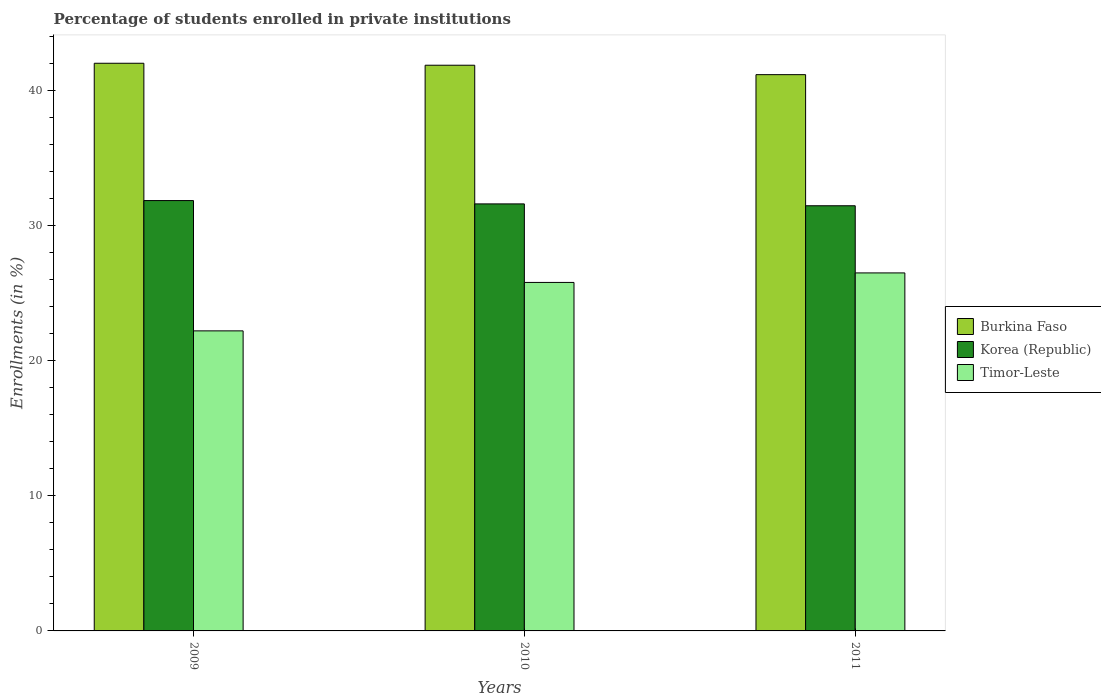How many groups of bars are there?
Offer a terse response. 3. Are the number of bars per tick equal to the number of legend labels?
Your answer should be very brief. Yes. Are the number of bars on each tick of the X-axis equal?
Make the answer very short. Yes. How many bars are there on the 2nd tick from the left?
Keep it short and to the point. 3. How many bars are there on the 2nd tick from the right?
Your answer should be compact. 3. What is the label of the 3rd group of bars from the left?
Make the answer very short. 2011. In how many cases, is the number of bars for a given year not equal to the number of legend labels?
Provide a short and direct response. 0. What is the percentage of trained teachers in Timor-Leste in 2011?
Give a very brief answer. 26.49. Across all years, what is the maximum percentage of trained teachers in Timor-Leste?
Your response must be concise. 26.49. Across all years, what is the minimum percentage of trained teachers in Burkina Faso?
Make the answer very short. 41.16. What is the total percentage of trained teachers in Timor-Leste in the graph?
Give a very brief answer. 74.48. What is the difference between the percentage of trained teachers in Timor-Leste in 2009 and that in 2011?
Your response must be concise. -4.29. What is the difference between the percentage of trained teachers in Burkina Faso in 2011 and the percentage of trained teachers in Korea (Republic) in 2010?
Provide a short and direct response. 9.56. What is the average percentage of trained teachers in Korea (Republic) per year?
Make the answer very short. 31.63. In the year 2010, what is the difference between the percentage of trained teachers in Korea (Republic) and percentage of trained teachers in Burkina Faso?
Provide a succinct answer. -10.26. What is the ratio of the percentage of trained teachers in Burkina Faso in 2009 to that in 2011?
Your answer should be compact. 1.02. Is the difference between the percentage of trained teachers in Korea (Republic) in 2009 and 2010 greater than the difference between the percentage of trained teachers in Burkina Faso in 2009 and 2010?
Give a very brief answer. Yes. What is the difference between the highest and the second highest percentage of trained teachers in Burkina Faso?
Make the answer very short. 0.15. What is the difference between the highest and the lowest percentage of trained teachers in Burkina Faso?
Keep it short and to the point. 0.84. Is the sum of the percentage of trained teachers in Korea (Republic) in 2010 and 2011 greater than the maximum percentage of trained teachers in Burkina Faso across all years?
Ensure brevity in your answer.  Yes. What does the 3rd bar from the left in 2009 represents?
Your response must be concise. Timor-Leste. What does the 2nd bar from the right in 2010 represents?
Keep it short and to the point. Korea (Republic). Is it the case that in every year, the sum of the percentage of trained teachers in Burkina Faso and percentage of trained teachers in Timor-Leste is greater than the percentage of trained teachers in Korea (Republic)?
Offer a very short reply. Yes. How many bars are there?
Offer a very short reply. 9. Are all the bars in the graph horizontal?
Provide a succinct answer. No. How many years are there in the graph?
Provide a succinct answer. 3. What is the difference between two consecutive major ticks on the Y-axis?
Offer a very short reply. 10. Does the graph contain any zero values?
Your response must be concise. No. What is the title of the graph?
Make the answer very short. Percentage of students enrolled in private institutions. What is the label or title of the Y-axis?
Your response must be concise. Enrollments (in %). What is the Enrollments (in %) in Burkina Faso in 2009?
Your answer should be very brief. 42. What is the Enrollments (in %) of Korea (Republic) in 2009?
Your answer should be compact. 31.84. What is the Enrollments (in %) in Timor-Leste in 2009?
Give a very brief answer. 22.2. What is the Enrollments (in %) of Burkina Faso in 2010?
Your response must be concise. 41.86. What is the Enrollments (in %) of Korea (Republic) in 2010?
Make the answer very short. 31.6. What is the Enrollments (in %) of Timor-Leste in 2010?
Offer a very short reply. 25.79. What is the Enrollments (in %) in Burkina Faso in 2011?
Make the answer very short. 41.16. What is the Enrollments (in %) of Korea (Republic) in 2011?
Keep it short and to the point. 31.46. What is the Enrollments (in %) of Timor-Leste in 2011?
Give a very brief answer. 26.49. Across all years, what is the maximum Enrollments (in %) of Burkina Faso?
Provide a succinct answer. 42. Across all years, what is the maximum Enrollments (in %) of Korea (Republic)?
Keep it short and to the point. 31.84. Across all years, what is the maximum Enrollments (in %) in Timor-Leste?
Give a very brief answer. 26.49. Across all years, what is the minimum Enrollments (in %) of Burkina Faso?
Give a very brief answer. 41.16. Across all years, what is the minimum Enrollments (in %) of Korea (Republic)?
Offer a terse response. 31.46. Across all years, what is the minimum Enrollments (in %) of Timor-Leste?
Offer a very short reply. 22.2. What is the total Enrollments (in %) of Burkina Faso in the graph?
Your answer should be compact. 125.02. What is the total Enrollments (in %) of Korea (Republic) in the graph?
Keep it short and to the point. 94.9. What is the total Enrollments (in %) of Timor-Leste in the graph?
Offer a very short reply. 74.48. What is the difference between the Enrollments (in %) of Burkina Faso in 2009 and that in 2010?
Ensure brevity in your answer.  0.15. What is the difference between the Enrollments (in %) of Korea (Republic) in 2009 and that in 2010?
Ensure brevity in your answer.  0.25. What is the difference between the Enrollments (in %) of Timor-Leste in 2009 and that in 2010?
Offer a terse response. -3.58. What is the difference between the Enrollments (in %) in Burkina Faso in 2009 and that in 2011?
Your response must be concise. 0.84. What is the difference between the Enrollments (in %) in Korea (Republic) in 2009 and that in 2011?
Offer a very short reply. 0.38. What is the difference between the Enrollments (in %) of Timor-Leste in 2009 and that in 2011?
Offer a terse response. -4.29. What is the difference between the Enrollments (in %) of Burkina Faso in 2010 and that in 2011?
Offer a terse response. 0.7. What is the difference between the Enrollments (in %) in Korea (Republic) in 2010 and that in 2011?
Provide a short and direct response. 0.14. What is the difference between the Enrollments (in %) of Timor-Leste in 2010 and that in 2011?
Give a very brief answer. -0.7. What is the difference between the Enrollments (in %) in Burkina Faso in 2009 and the Enrollments (in %) in Korea (Republic) in 2010?
Ensure brevity in your answer.  10.41. What is the difference between the Enrollments (in %) in Burkina Faso in 2009 and the Enrollments (in %) in Timor-Leste in 2010?
Ensure brevity in your answer.  16.22. What is the difference between the Enrollments (in %) in Korea (Republic) in 2009 and the Enrollments (in %) in Timor-Leste in 2010?
Make the answer very short. 6.06. What is the difference between the Enrollments (in %) in Burkina Faso in 2009 and the Enrollments (in %) in Korea (Republic) in 2011?
Your response must be concise. 10.54. What is the difference between the Enrollments (in %) of Burkina Faso in 2009 and the Enrollments (in %) of Timor-Leste in 2011?
Offer a terse response. 15.51. What is the difference between the Enrollments (in %) in Korea (Republic) in 2009 and the Enrollments (in %) in Timor-Leste in 2011?
Provide a short and direct response. 5.35. What is the difference between the Enrollments (in %) in Burkina Faso in 2010 and the Enrollments (in %) in Korea (Republic) in 2011?
Your response must be concise. 10.4. What is the difference between the Enrollments (in %) of Burkina Faso in 2010 and the Enrollments (in %) of Timor-Leste in 2011?
Your response must be concise. 15.37. What is the difference between the Enrollments (in %) in Korea (Republic) in 2010 and the Enrollments (in %) in Timor-Leste in 2011?
Your response must be concise. 5.11. What is the average Enrollments (in %) of Burkina Faso per year?
Provide a short and direct response. 41.67. What is the average Enrollments (in %) of Korea (Republic) per year?
Provide a short and direct response. 31.63. What is the average Enrollments (in %) in Timor-Leste per year?
Offer a terse response. 24.83. In the year 2009, what is the difference between the Enrollments (in %) of Burkina Faso and Enrollments (in %) of Korea (Republic)?
Your response must be concise. 10.16. In the year 2009, what is the difference between the Enrollments (in %) of Burkina Faso and Enrollments (in %) of Timor-Leste?
Give a very brief answer. 19.8. In the year 2009, what is the difference between the Enrollments (in %) of Korea (Republic) and Enrollments (in %) of Timor-Leste?
Provide a succinct answer. 9.64. In the year 2010, what is the difference between the Enrollments (in %) of Burkina Faso and Enrollments (in %) of Korea (Republic)?
Your answer should be compact. 10.26. In the year 2010, what is the difference between the Enrollments (in %) in Burkina Faso and Enrollments (in %) in Timor-Leste?
Ensure brevity in your answer.  16.07. In the year 2010, what is the difference between the Enrollments (in %) of Korea (Republic) and Enrollments (in %) of Timor-Leste?
Your answer should be compact. 5.81. In the year 2011, what is the difference between the Enrollments (in %) of Burkina Faso and Enrollments (in %) of Korea (Republic)?
Provide a succinct answer. 9.7. In the year 2011, what is the difference between the Enrollments (in %) of Burkina Faso and Enrollments (in %) of Timor-Leste?
Your answer should be very brief. 14.67. In the year 2011, what is the difference between the Enrollments (in %) of Korea (Republic) and Enrollments (in %) of Timor-Leste?
Offer a terse response. 4.97. What is the ratio of the Enrollments (in %) of Timor-Leste in 2009 to that in 2010?
Ensure brevity in your answer.  0.86. What is the ratio of the Enrollments (in %) of Burkina Faso in 2009 to that in 2011?
Your response must be concise. 1.02. What is the ratio of the Enrollments (in %) of Korea (Republic) in 2009 to that in 2011?
Your answer should be compact. 1.01. What is the ratio of the Enrollments (in %) of Timor-Leste in 2009 to that in 2011?
Provide a short and direct response. 0.84. What is the ratio of the Enrollments (in %) of Burkina Faso in 2010 to that in 2011?
Ensure brevity in your answer.  1.02. What is the ratio of the Enrollments (in %) of Korea (Republic) in 2010 to that in 2011?
Ensure brevity in your answer.  1. What is the ratio of the Enrollments (in %) in Timor-Leste in 2010 to that in 2011?
Keep it short and to the point. 0.97. What is the difference between the highest and the second highest Enrollments (in %) of Burkina Faso?
Ensure brevity in your answer.  0.15. What is the difference between the highest and the second highest Enrollments (in %) of Korea (Republic)?
Your response must be concise. 0.25. What is the difference between the highest and the second highest Enrollments (in %) in Timor-Leste?
Your answer should be compact. 0.7. What is the difference between the highest and the lowest Enrollments (in %) of Burkina Faso?
Ensure brevity in your answer.  0.84. What is the difference between the highest and the lowest Enrollments (in %) of Korea (Republic)?
Offer a terse response. 0.38. What is the difference between the highest and the lowest Enrollments (in %) of Timor-Leste?
Your answer should be compact. 4.29. 